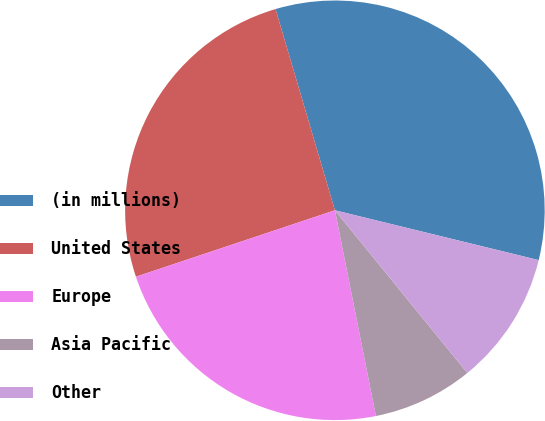Convert chart to OTSL. <chart><loc_0><loc_0><loc_500><loc_500><pie_chart><fcel>(in millions)<fcel>United States<fcel>Europe<fcel>Asia Pacific<fcel>Other<nl><fcel>33.38%<fcel>25.56%<fcel>23.0%<fcel>7.74%<fcel>10.31%<nl></chart> 